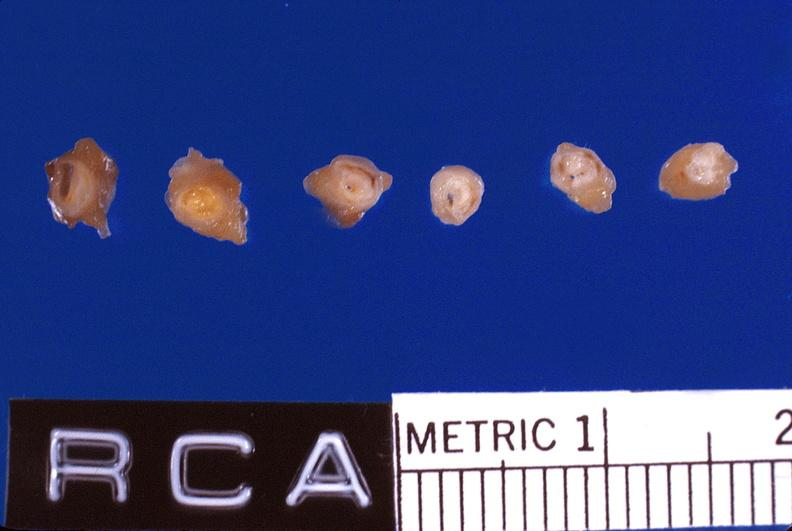s anencephaly present?
Answer the question using a single word or phrase. No 